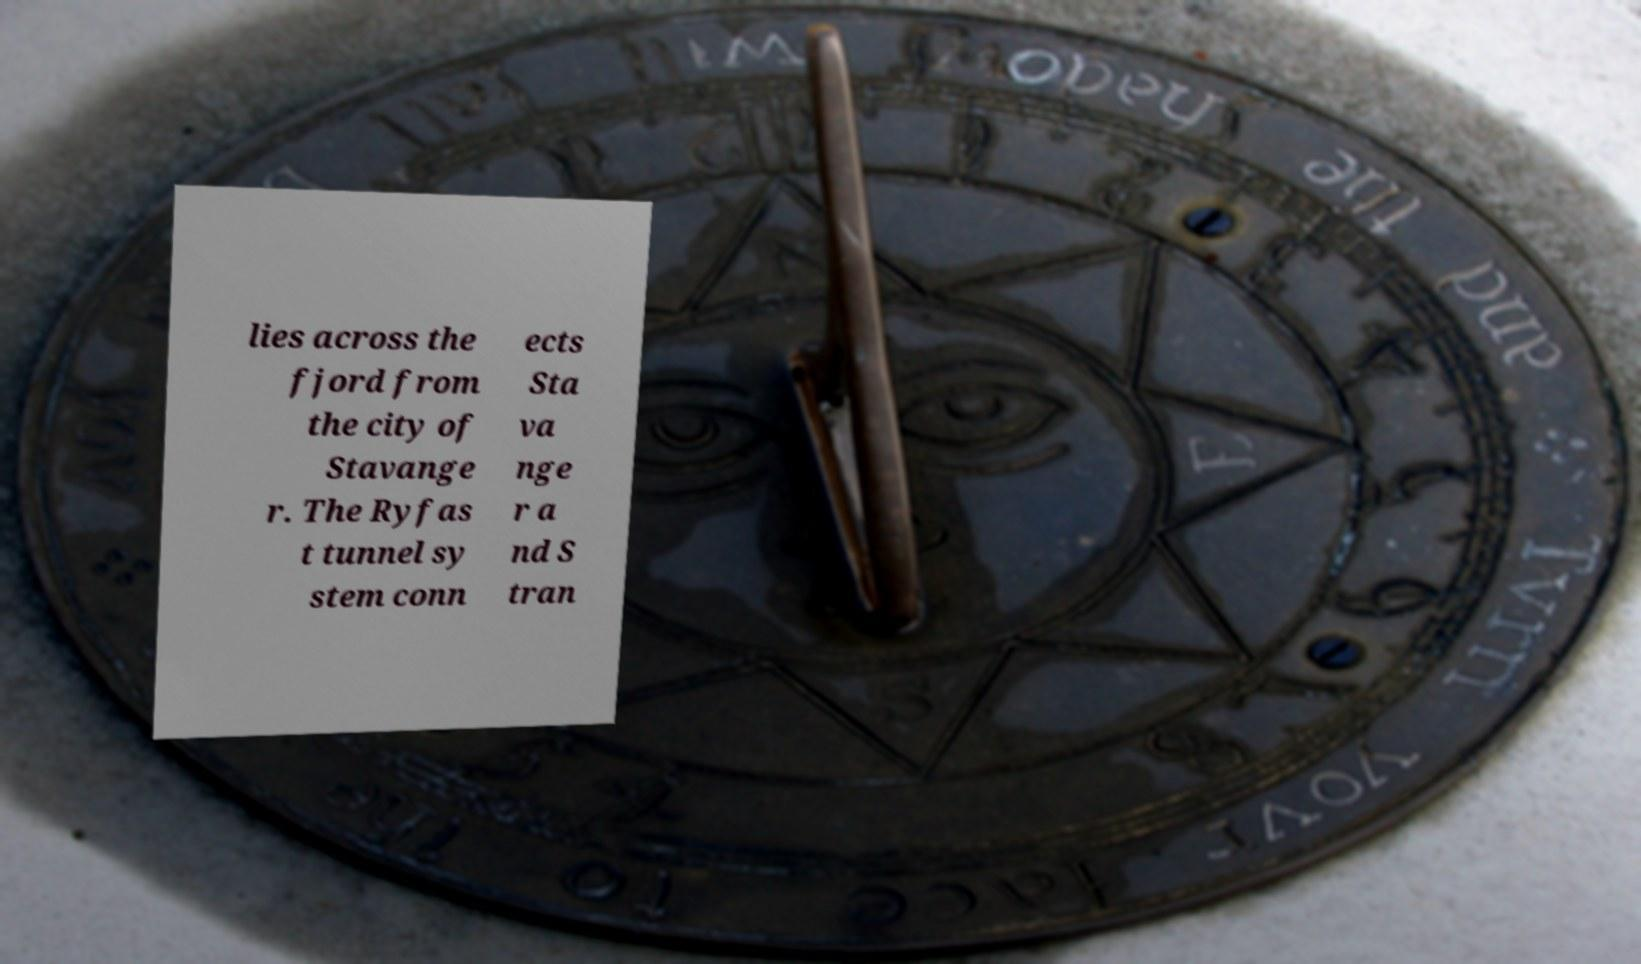There's text embedded in this image that I need extracted. Can you transcribe it verbatim? lies across the fjord from the city of Stavange r. The Ryfas t tunnel sy stem conn ects Sta va nge r a nd S tran 